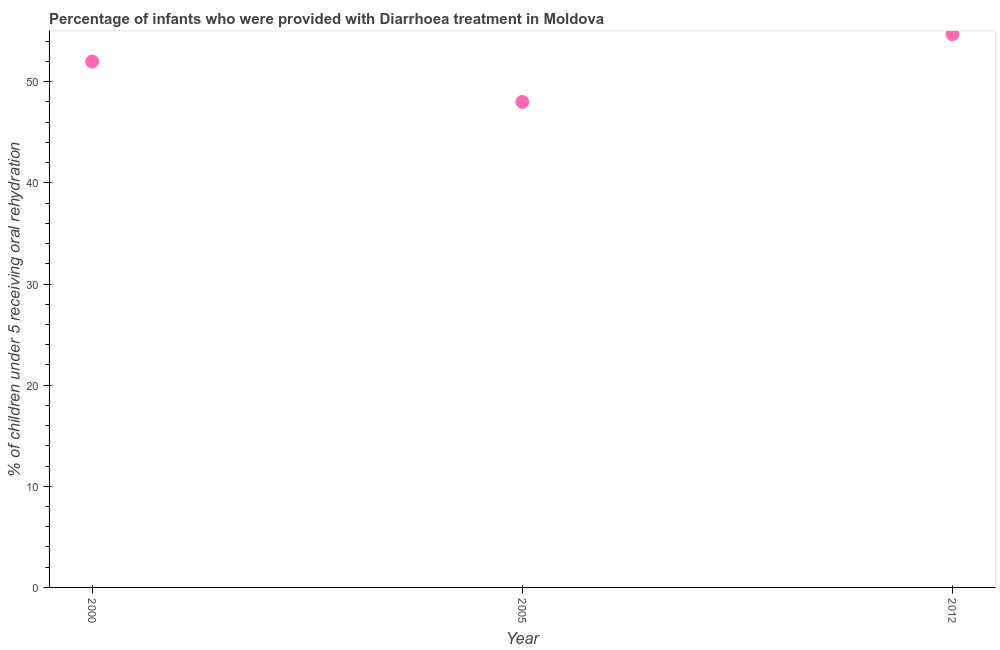What is the percentage of children who were provided with treatment diarrhoea in 2012?
Your answer should be very brief. 54.7. Across all years, what is the maximum percentage of children who were provided with treatment diarrhoea?
Keep it short and to the point. 54.7. Across all years, what is the minimum percentage of children who were provided with treatment diarrhoea?
Your answer should be very brief. 48. In which year was the percentage of children who were provided with treatment diarrhoea minimum?
Give a very brief answer. 2005. What is the sum of the percentage of children who were provided with treatment diarrhoea?
Provide a succinct answer. 154.7. What is the difference between the percentage of children who were provided with treatment diarrhoea in 2000 and 2005?
Your response must be concise. 4. What is the average percentage of children who were provided with treatment diarrhoea per year?
Your answer should be compact. 51.57. What is the median percentage of children who were provided with treatment diarrhoea?
Offer a terse response. 52. What is the ratio of the percentage of children who were provided with treatment diarrhoea in 2005 to that in 2012?
Your answer should be very brief. 0.88. Is the percentage of children who were provided with treatment diarrhoea in 2000 less than that in 2005?
Give a very brief answer. No. What is the difference between the highest and the second highest percentage of children who were provided with treatment diarrhoea?
Make the answer very short. 2.7. Is the sum of the percentage of children who were provided with treatment diarrhoea in 2000 and 2012 greater than the maximum percentage of children who were provided with treatment diarrhoea across all years?
Keep it short and to the point. Yes. What is the difference between the highest and the lowest percentage of children who were provided with treatment diarrhoea?
Give a very brief answer. 6.7. Does the percentage of children who were provided with treatment diarrhoea monotonically increase over the years?
Keep it short and to the point. No. What is the difference between two consecutive major ticks on the Y-axis?
Keep it short and to the point. 10. Are the values on the major ticks of Y-axis written in scientific E-notation?
Provide a short and direct response. No. What is the title of the graph?
Ensure brevity in your answer.  Percentage of infants who were provided with Diarrhoea treatment in Moldova. What is the label or title of the Y-axis?
Your response must be concise. % of children under 5 receiving oral rehydration. What is the % of children under 5 receiving oral rehydration in 2005?
Offer a terse response. 48. What is the % of children under 5 receiving oral rehydration in 2012?
Keep it short and to the point. 54.7. What is the difference between the % of children under 5 receiving oral rehydration in 2005 and 2012?
Offer a terse response. -6.7. What is the ratio of the % of children under 5 receiving oral rehydration in 2000 to that in 2005?
Your answer should be compact. 1.08. What is the ratio of the % of children under 5 receiving oral rehydration in 2000 to that in 2012?
Keep it short and to the point. 0.95. What is the ratio of the % of children under 5 receiving oral rehydration in 2005 to that in 2012?
Make the answer very short. 0.88. 